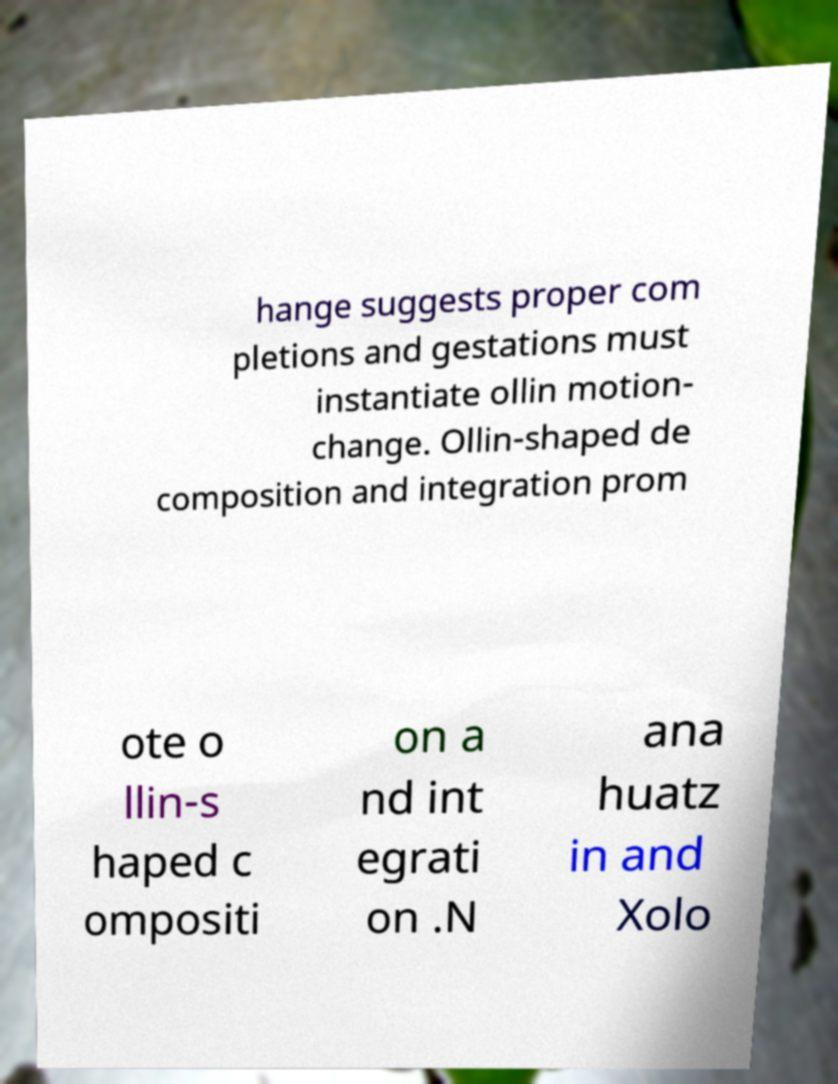Please read and relay the text visible in this image. What does it say? hange suggests proper com pletions and gestations must instantiate ollin motion- change. Ollin-shaped de composition and integration prom ote o llin-s haped c ompositi on a nd int egrati on .N ana huatz in and Xolo 